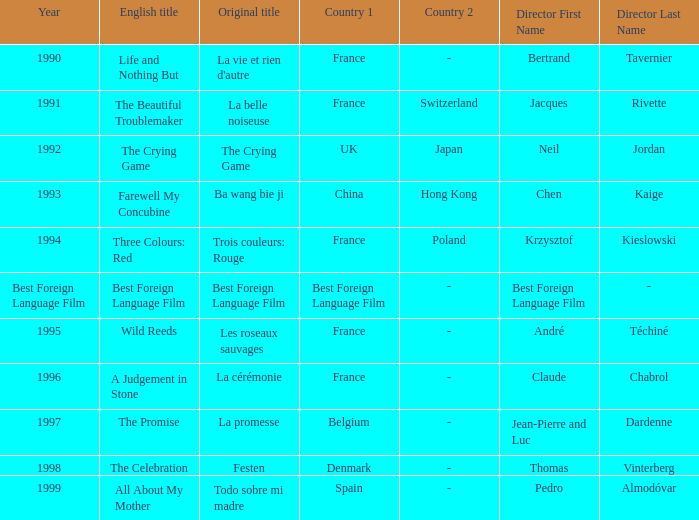Which Country is listed for the Director Thomas Vinterberg? Denmark. 